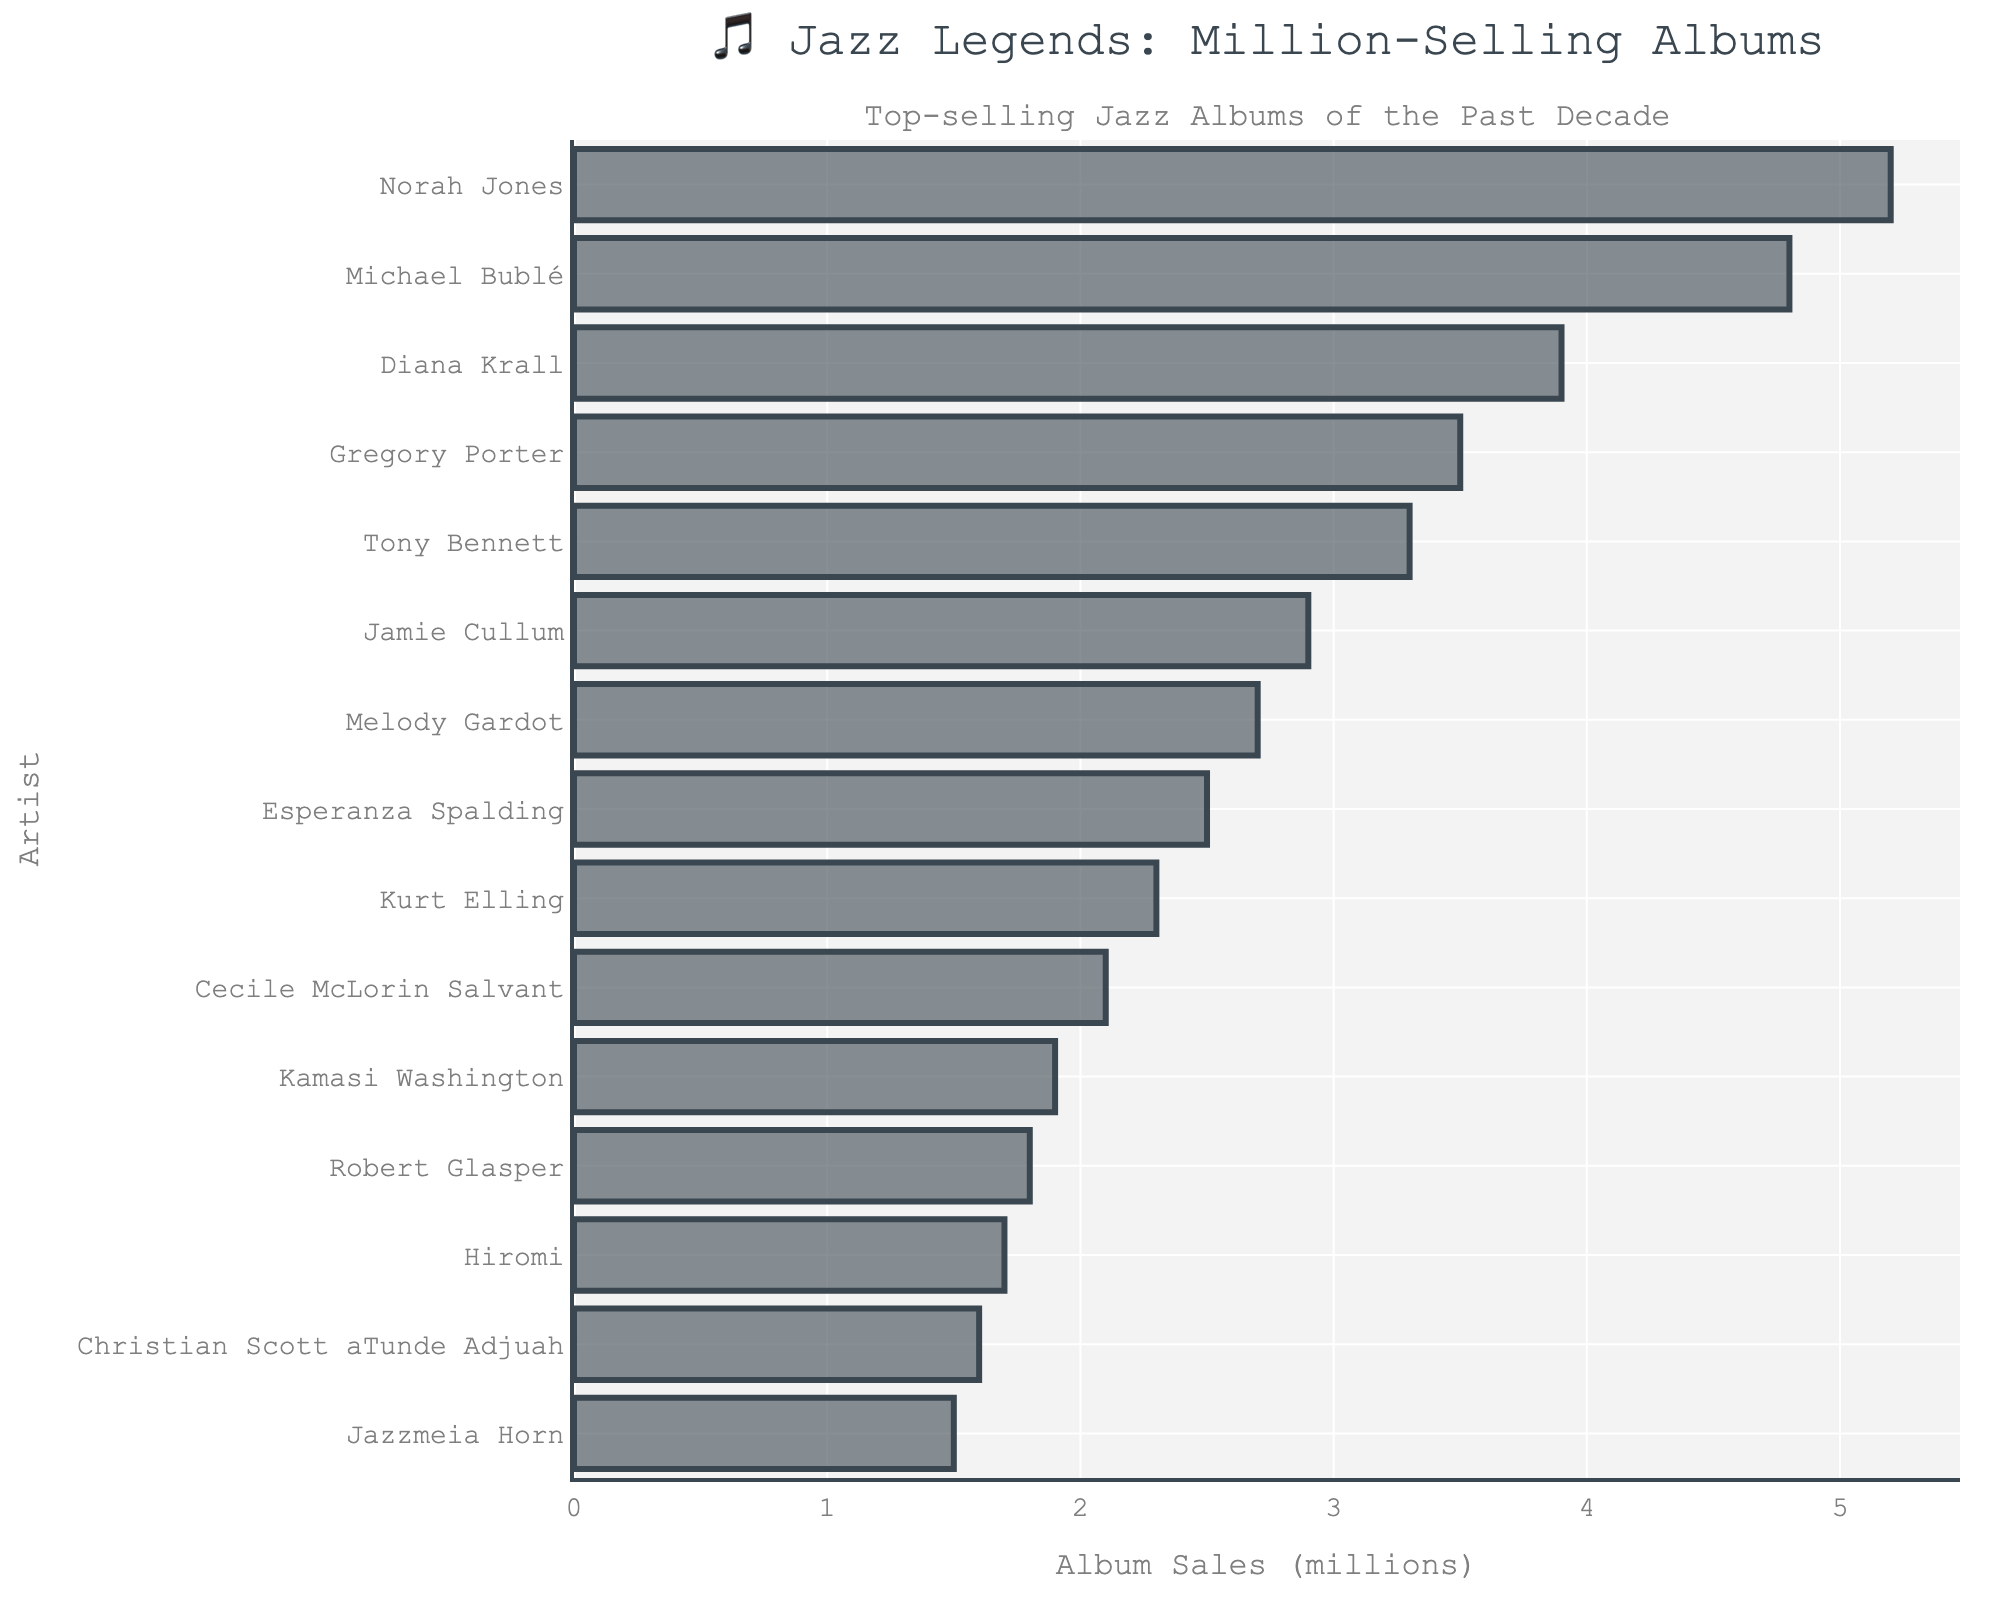Which artist has the highest album sales? By looking at the length of the bars, Norah Jones has the longest bar, indicating the highest album sales.
Answer: Norah Jones Which artist sold fewer albums, Jamie Cullum or Melody Gardot? Comparing the lengths of the bars for Jamie Cullum and Melody Gardot, Melody Gardot's bar is shorter, meaning she sold fewer albums.
Answer: Melody Gardot What is the total album sales of Gregory Porter and Tony Bennett combined? Gregory Porter sold 3.5 million albums and Tony Bennett sold 3.3 million albums. Adding these together, 3.5 + 3.3 = 6.8
Answer: 6.8 million Who sold more albums, Esperanza Spalding or Kurt Elling? Comparing the lengths of the bars for Esperanza Spalding and Kurt Elling, Esperanza Spalding's bar is longer, indicating she sold more albums.
Answer: Esperanza Spalding Which three artists have the lowest album sales? The shortest bars belong to Jazzmeia Horn, Christian Scott aTunde Adjuah, and Hiromi. These three artists have the lowest album sales.
Answer: Jazzmeia Horn, Christian Scott aTunde Adjuah, Hiromi How much more did Norah Jones sell than Kamasi Washington? Norah Jones sold 5.2 million albums and Kamasi Washington sold 1.9 million albums. The difference is 5.2 - 1.9 = 3.3
Answer: 3.3 million What is the total album sales of the top 5 artists combined? The top 5 artists are Norah Jones (5.2), Michael Bublé (4.8), Diana Krall (3.9), Gregory Porter (3.5), and Tony Bennett (3.3). Adding these together, 5.2 + 4.8 + 3.9 + 3.5 + 3.3 = 20.7
Answer: 20.7 million Who sold just under 2 million albums? The bar closest to, but under, 2 million belongs to Kamasi Washington, who sold 1.9 million albums.
Answer: Kamasi Washington What is the average album sales for the artists who sold more than 3 million albums? The artists are Norah Jones (5.2), Michael Bublé (4.8), Diana Krall (3.9), Gregory Porter (3.5), and Tony Bennett (3.3). The total is 5.2 + 4.8 + 3.9 + 3.5 + 3.3 = 20.7. There are 5 artists, so the average is 20.7 / 5 = 4.14
Answer: 4.14 million 